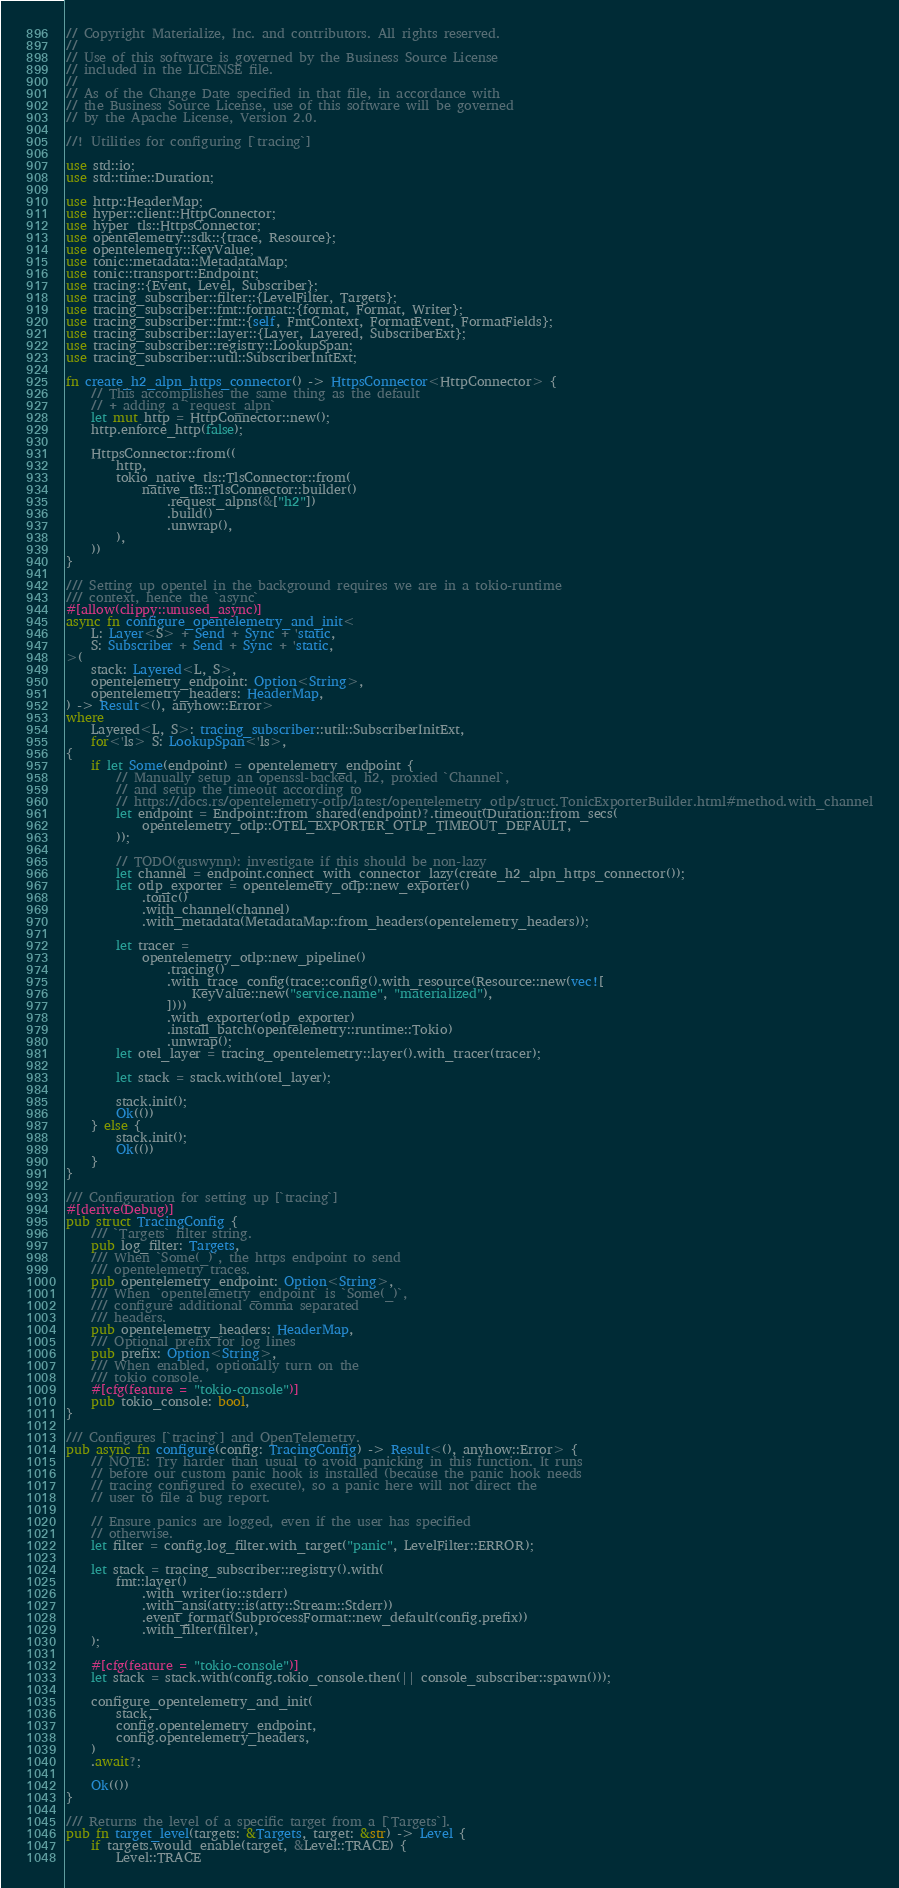<code> <loc_0><loc_0><loc_500><loc_500><_Rust_>// Copyright Materialize, Inc. and contributors. All rights reserved.
//
// Use of this software is governed by the Business Source License
// included in the LICENSE file.
//
// As of the Change Date specified in that file, in accordance with
// the Business Source License, use of this software will be governed
// by the Apache License, Version 2.0.

//! Utilities for configuring [`tracing`]

use std::io;
use std::time::Duration;

use http::HeaderMap;
use hyper::client::HttpConnector;
use hyper_tls::HttpsConnector;
use opentelemetry::sdk::{trace, Resource};
use opentelemetry::KeyValue;
use tonic::metadata::MetadataMap;
use tonic::transport::Endpoint;
use tracing::{Event, Level, Subscriber};
use tracing_subscriber::filter::{LevelFilter, Targets};
use tracing_subscriber::fmt::format::{format, Format, Writer};
use tracing_subscriber::fmt::{self, FmtContext, FormatEvent, FormatFields};
use tracing_subscriber::layer::{Layer, Layered, SubscriberExt};
use tracing_subscriber::registry::LookupSpan;
use tracing_subscriber::util::SubscriberInitExt;

fn create_h2_alpn_https_connector() -> HttpsConnector<HttpConnector> {
    // This accomplishes the same thing as the default
    // + adding a `request_alpn`
    let mut http = HttpConnector::new();
    http.enforce_http(false);

    HttpsConnector::from((
        http,
        tokio_native_tls::TlsConnector::from(
            native_tls::TlsConnector::builder()
                .request_alpns(&["h2"])
                .build()
                .unwrap(),
        ),
    ))
}

/// Setting up opentel in the background requires we are in a tokio-runtime
/// context, hence the `async`
#[allow(clippy::unused_async)]
async fn configure_opentelemetry_and_init<
    L: Layer<S> + Send + Sync + 'static,
    S: Subscriber + Send + Sync + 'static,
>(
    stack: Layered<L, S>,
    opentelemetry_endpoint: Option<String>,
    opentelemetry_headers: HeaderMap,
) -> Result<(), anyhow::Error>
where
    Layered<L, S>: tracing_subscriber::util::SubscriberInitExt,
    for<'ls> S: LookupSpan<'ls>,
{
    if let Some(endpoint) = opentelemetry_endpoint {
        // Manually setup an openssl-backed, h2, proxied `Channel`,
        // and setup the timeout according to
        // https://docs.rs/opentelemetry-otlp/latest/opentelemetry_otlp/struct.TonicExporterBuilder.html#method.with_channel
        let endpoint = Endpoint::from_shared(endpoint)?.timeout(Duration::from_secs(
            opentelemetry_otlp::OTEL_EXPORTER_OTLP_TIMEOUT_DEFAULT,
        ));

        // TODO(guswynn): investigate if this should be non-lazy
        let channel = endpoint.connect_with_connector_lazy(create_h2_alpn_https_connector());
        let otlp_exporter = opentelemetry_otlp::new_exporter()
            .tonic()
            .with_channel(channel)
            .with_metadata(MetadataMap::from_headers(opentelemetry_headers));

        let tracer =
            opentelemetry_otlp::new_pipeline()
                .tracing()
                .with_trace_config(trace::config().with_resource(Resource::new(vec![
                    KeyValue::new("service.name", "materialized"),
                ])))
                .with_exporter(otlp_exporter)
                .install_batch(opentelemetry::runtime::Tokio)
                .unwrap();
        let otel_layer = tracing_opentelemetry::layer().with_tracer(tracer);

        let stack = stack.with(otel_layer);

        stack.init();
        Ok(())
    } else {
        stack.init();
        Ok(())
    }
}

/// Configuration for setting up [`tracing`]
#[derive(Debug)]
pub struct TracingConfig {
    /// `Targets` filter string.
    pub log_filter: Targets,
    /// When `Some(_)`, the https endpoint to send
    /// opentelemetry traces.
    pub opentelemetry_endpoint: Option<String>,
    /// When `opentelemetry_endpoint` is `Some(_)`,
    /// configure additional comma separated
    /// headers.
    pub opentelemetry_headers: HeaderMap,
    /// Optional prefix for log lines
    pub prefix: Option<String>,
    /// When enabled, optionally turn on the
    /// tokio console.
    #[cfg(feature = "tokio-console")]
    pub tokio_console: bool,
}

/// Configures [`tracing`] and OpenTelemetry.
pub async fn configure(config: TracingConfig) -> Result<(), anyhow::Error> {
    // NOTE: Try harder than usual to avoid panicking in this function. It runs
    // before our custom panic hook is installed (because the panic hook needs
    // tracing configured to execute), so a panic here will not direct the
    // user to file a bug report.

    // Ensure panics are logged, even if the user has specified
    // otherwise.
    let filter = config.log_filter.with_target("panic", LevelFilter::ERROR);

    let stack = tracing_subscriber::registry().with(
        fmt::layer()
            .with_writer(io::stderr)
            .with_ansi(atty::is(atty::Stream::Stderr))
            .event_format(SubprocessFormat::new_default(config.prefix))
            .with_filter(filter),
    );

    #[cfg(feature = "tokio-console")]
    let stack = stack.with(config.tokio_console.then(|| console_subscriber::spawn()));

    configure_opentelemetry_and_init(
        stack,
        config.opentelemetry_endpoint,
        config.opentelemetry_headers,
    )
    .await?;

    Ok(())
}

/// Returns the level of a specific target from a [`Targets`].
pub fn target_level(targets: &Targets, target: &str) -> Level {
    if targets.would_enable(target, &Level::TRACE) {
        Level::TRACE</code> 